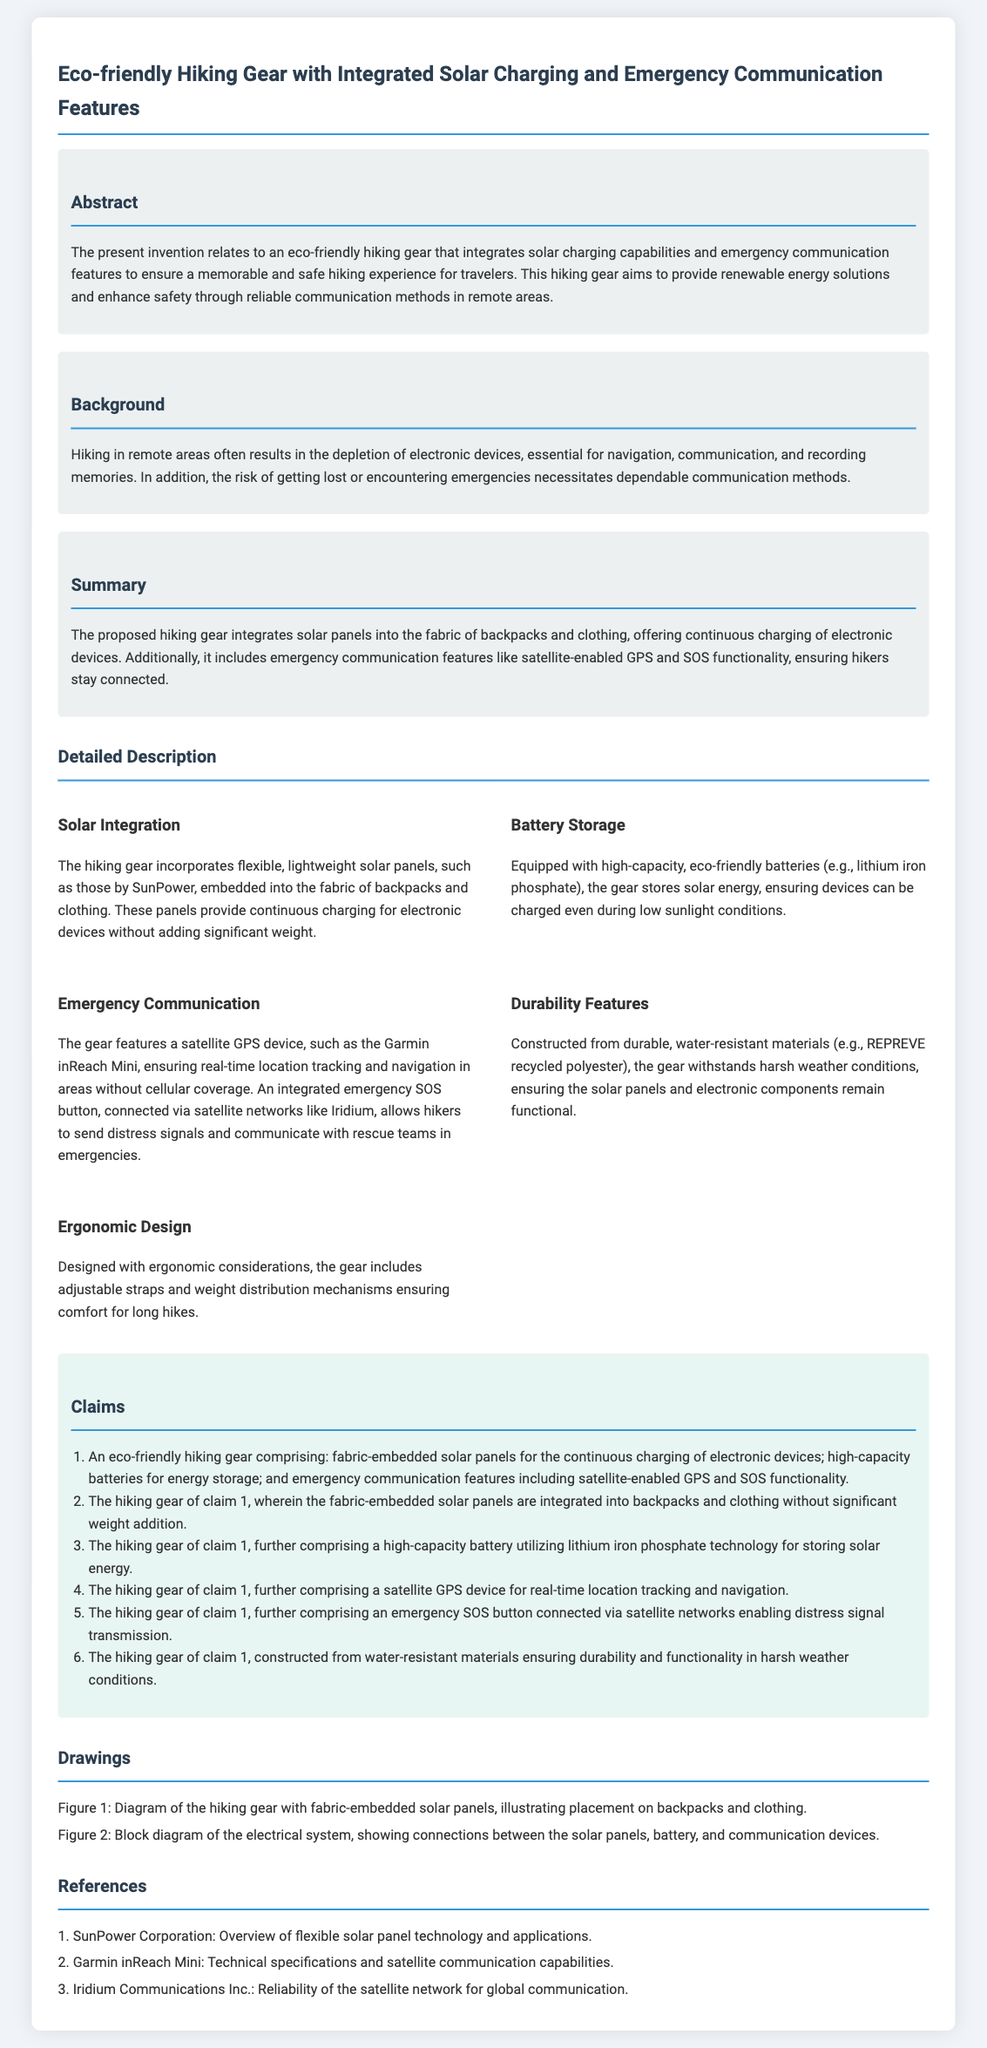what features does the hiking gear integrate? The hiking gear integrates solar charging capabilities and emergency communication features.
Answer: solar charging and emergency communication what type of panels are embedded in the hiking gear? The document specifies that flexible, lightweight solar panels are embedded in the fabric.
Answer: flexible, lightweight solar panels what type of battery is used for energy storage? The hiking gear is equipped with high-capacity, eco-friendly batteries using lithium iron phosphate technology.
Answer: lithium iron phosphate how does the emergency communication feature function? It includes a satellite GPS device for real-time tracking and an SOS button connected via satellite networks.
Answer: satellite GPS and SOS button what materials are used to construct the hiking gear? The gear is constructed from durable, water-resistant materials.
Answer: water-resistant materials how many claims are listed in the patent application? Claims are enumerated in the document, and there are six claims associated with the hiking gear.
Answer: six claims what is the purpose of the solar integration? The solar integration aims to provide continuous charging of electronic devices.
Answer: continuous charging which company provides the solar panel technology referenced in the document? The document refers to SunPower Corporation for the solar panel technology.
Answer: SunPower Corporation 